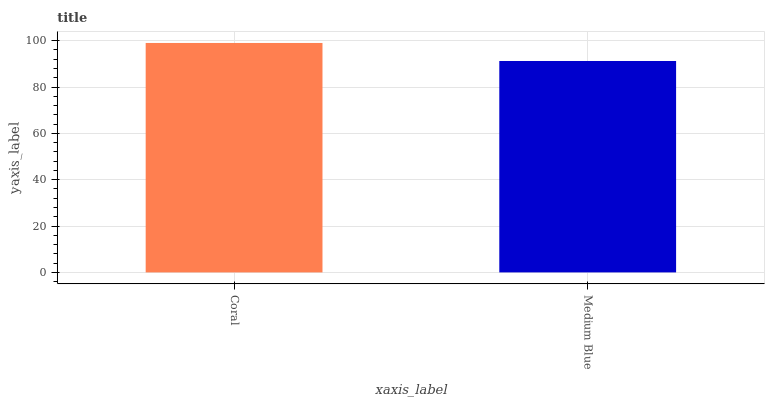Is Medium Blue the minimum?
Answer yes or no. Yes. Is Coral the maximum?
Answer yes or no. Yes. Is Medium Blue the maximum?
Answer yes or no. No. Is Coral greater than Medium Blue?
Answer yes or no. Yes. Is Medium Blue less than Coral?
Answer yes or no. Yes. Is Medium Blue greater than Coral?
Answer yes or no. No. Is Coral less than Medium Blue?
Answer yes or no. No. Is Coral the high median?
Answer yes or no. Yes. Is Medium Blue the low median?
Answer yes or no. Yes. Is Medium Blue the high median?
Answer yes or no. No. Is Coral the low median?
Answer yes or no. No. 